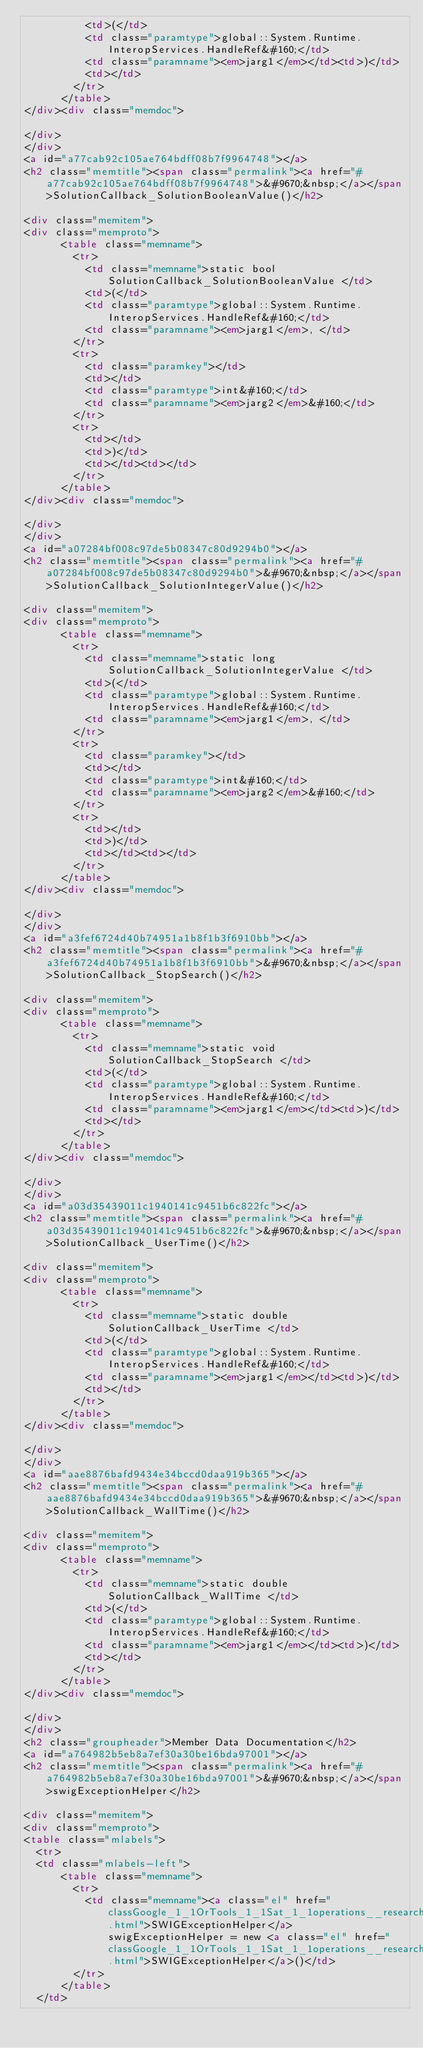<code> <loc_0><loc_0><loc_500><loc_500><_HTML_>          <td>(</td>
          <td class="paramtype">global::System.Runtime.InteropServices.HandleRef&#160;</td>
          <td class="paramname"><em>jarg1</em></td><td>)</td>
          <td></td>
        </tr>
      </table>
</div><div class="memdoc">

</div>
</div>
<a id="a77cab92c105ae764bdff08b7f9964748"></a>
<h2 class="memtitle"><span class="permalink"><a href="#a77cab92c105ae764bdff08b7f9964748">&#9670;&nbsp;</a></span>SolutionCallback_SolutionBooleanValue()</h2>

<div class="memitem">
<div class="memproto">
      <table class="memname">
        <tr>
          <td class="memname">static bool SolutionCallback_SolutionBooleanValue </td>
          <td>(</td>
          <td class="paramtype">global::System.Runtime.InteropServices.HandleRef&#160;</td>
          <td class="paramname"><em>jarg1</em>, </td>
        </tr>
        <tr>
          <td class="paramkey"></td>
          <td></td>
          <td class="paramtype">int&#160;</td>
          <td class="paramname"><em>jarg2</em>&#160;</td>
        </tr>
        <tr>
          <td></td>
          <td>)</td>
          <td></td><td></td>
        </tr>
      </table>
</div><div class="memdoc">

</div>
</div>
<a id="a07284bf008c97de5b08347c80d9294b0"></a>
<h2 class="memtitle"><span class="permalink"><a href="#a07284bf008c97de5b08347c80d9294b0">&#9670;&nbsp;</a></span>SolutionCallback_SolutionIntegerValue()</h2>

<div class="memitem">
<div class="memproto">
      <table class="memname">
        <tr>
          <td class="memname">static long SolutionCallback_SolutionIntegerValue </td>
          <td>(</td>
          <td class="paramtype">global::System.Runtime.InteropServices.HandleRef&#160;</td>
          <td class="paramname"><em>jarg1</em>, </td>
        </tr>
        <tr>
          <td class="paramkey"></td>
          <td></td>
          <td class="paramtype">int&#160;</td>
          <td class="paramname"><em>jarg2</em>&#160;</td>
        </tr>
        <tr>
          <td></td>
          <td>)</td>
          <td></td><td></td>
        </tr>
      </table>
</div><div class="memdoc">

</div>
</div>
<a id="a3fef6724d40b74951a1b8f1b3f6910bb"></a>
<h2 class="memtitle"><span class="permalink"><a href="#a3fef6724d40b74951a1b8f1b3f6910bb">&#9670;&nbsp;</a></span>SolutionCallback_StopSearch()</h2>

<div class="memitem">
<div class="memproto">
      <table class="memname">
        <tr>
          <td class="memname">static void SolutionCallback_StopSearch </td>
          <td>(</td>
          <td class="paramtype">global::System.Runtime.InteropServices.HandleRef&#160;</td>
          <td class="paramname"><em>jarg1</em></td><td>)</td>
          <td></td>
        </tr>
      </table>
</div><div class="memdoc">

</div>
</div>
<a id="a03d35439011c1940141c9451b6c822fc"></a>
<h2 class="memtitle"><span class="permalink"><a href="#a03d35439011c1940141c9451b6c822fc">&#9670;&nbsp;</a></span>SolutionCallback_UserTime()</h2>

<div class="memitem">
<div class="memproto">
      <table class="memname">
        <tr>
          <td class="memname">static double SolutionCallback_UserTime </td>
          <td>(</td>
          <td class="paramtype">global::System.Runtime.InteropServices.HandleRef&#160;</td>
          <td class="paramname"><em>jarg1</em></td><td>)</td>
          <td></td>
        </tr>
      </table>
</div><div class="memdoc">

</div>
</div>
<a id="aae8876bafd9434e34bccd0daa919b365"></a>
<h2 class="memtitle"><span class="permalink"><a href="#aae8876bafd9434e34bccd0daa919b365">&#9670;&nbsp;</a></span>SolutionCallback_WallTime()</h2>

<div class="memitem">
<div class="memproto">
      <table class="memname">
        <tr>
          <td class="memname">static double SolutionCallback_WallTime </td>
          <td>(</td>
          <td class="paramtype">global::System.Runtime.InteropServices.HandleRef&#160;</td>
          <td class="paramname"><em>jarg1</em></td><td>)</td>
          <td></td>
        </tr>
      </table>
</div><div class="memdoc">

</div>
</div>
<h2 class="groupheader">Member Data Documentation</h2>
<a id="a764982b5eb8a7ef30a30be16bda97001"></a>
<h2 class="memtitle"><span class="permalink"><a href="#a764982b5eb8a7ef30a30be16bda97001">&#9670;&nbsp;</a></span>swigExceptionHelper</h2>

<div class="memitem">
<div class="memproto">
<table class="mlabels">
  <tr>
  <td class="mlabels-left">
      <table class="memname">
        <tr>
          <td class="memname"><a class="el" href="classGoogle_1_1OrTools_1_1Sat_1_1operations__research__satPINVOKE_1_1SWIGExceptionHelper.html">SWIGExceptionHelper</a> swigExceptionHelper = new <a class="el" href="classGoogle_1_1OrTools_1_1Sat_1_1operations__research__satPINVOKE_1_1SWIGExceptionHelper.html">SWIGExceptionHelper</a>()</td>
        </tr>
      </table>
  </td></code> 